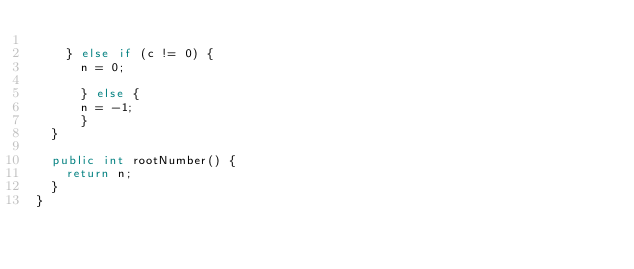Convert code to text. <code><loc_0><loc_0><loc_500><loc_500><_Java_>
    } else if (c != 0) {
      n = 0;

      } else {
      n = -1;
      }
  }

  public int rootNumber() {
    return n;
  }
}
</code> 